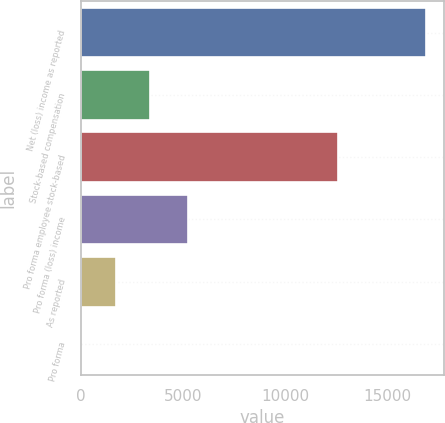Convert chart to OTSL. <chart><loc_0><loc_0><loc_500><loc_500><bar_chart><fcel>Net (loss) income as reported<fcel>Stock-based compensation<fcel>Pro forma employee stock-based<fcel>Pro forma (loss) income<fcel>As reported<fcel>Pro forma<nl><fcel>16889<fcel>3377.84<fcel>12570<fcel>5249<fcel>1688.94<fcel>0.04<nl></chart> 